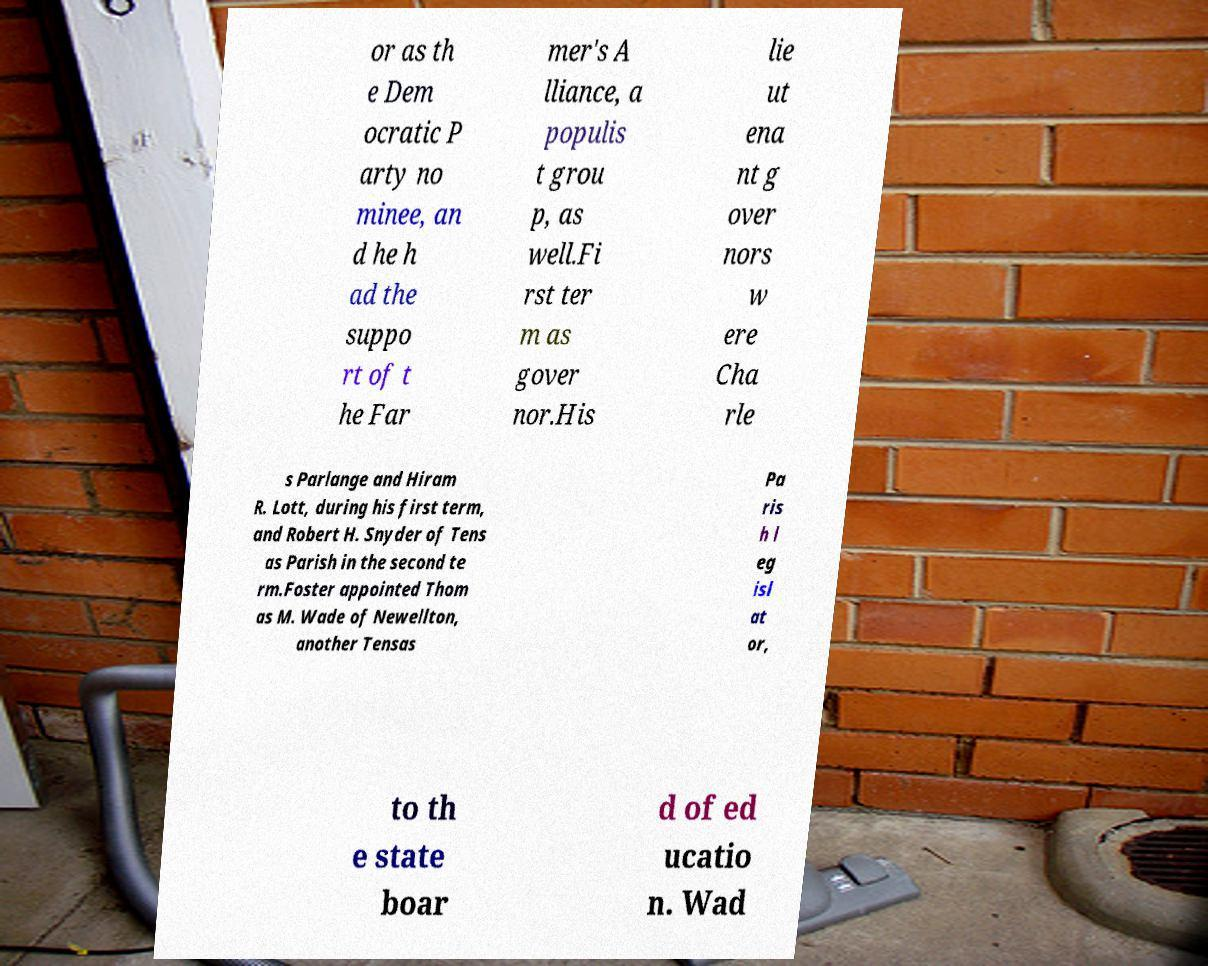Please read and relay the text visible in this image. What does it say? or as th e Dem ocratic P arty no minee, an d he h ad the suppo rt of t he Far mer's A lliance, a populis t grou p, as well.Fi rst ter m as gover nor.His lie ut ena nt g over nors w ere Cha rle s Parlange and Hiram R. Lott, during his first term, and Robert H. Snyder of Tens as Parish in the second te rm.Foster appointed Thom as M. Wade of Newellton, another Tensas Pa ris h l eg isl at or, to th e state boar d of ed ucatio n. Wad 